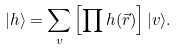<formula> <loc_0><loc_0><loc_500><loc_500>| h \rangle = \sum _ { v } \left [ \prod h ( \vec { r } ) \right ] | v \rangle .</formula> 